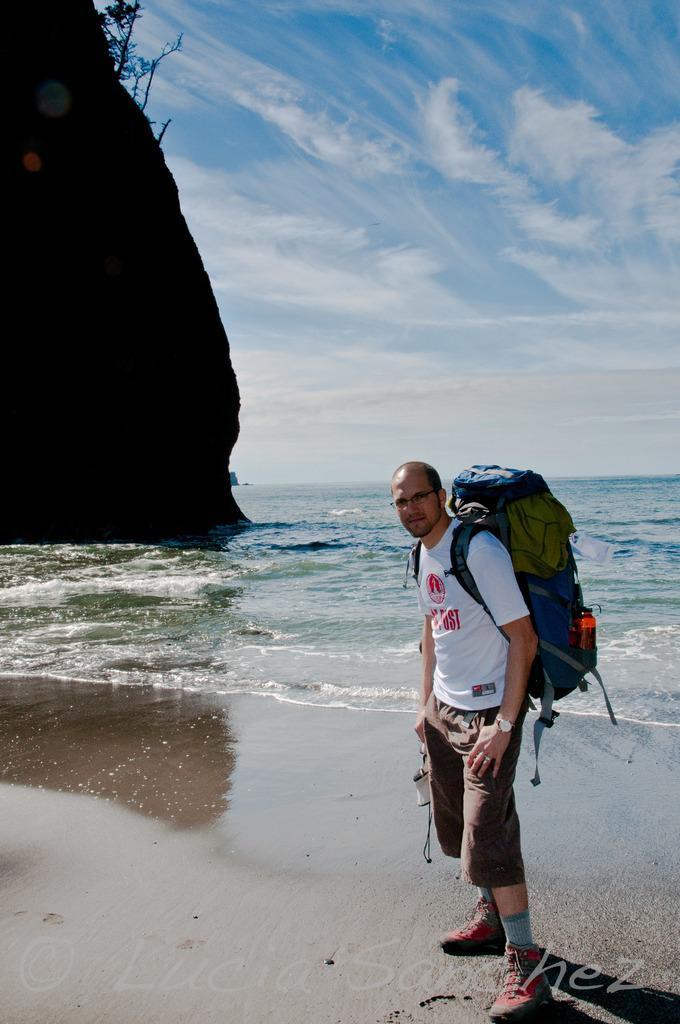In one or two sentences, can you explain what this image depicts? In this picture I can see a man standing with a backpack, there is a hill, there are trees, there is water, and in the background there is sky and there is a watermark on the image. 